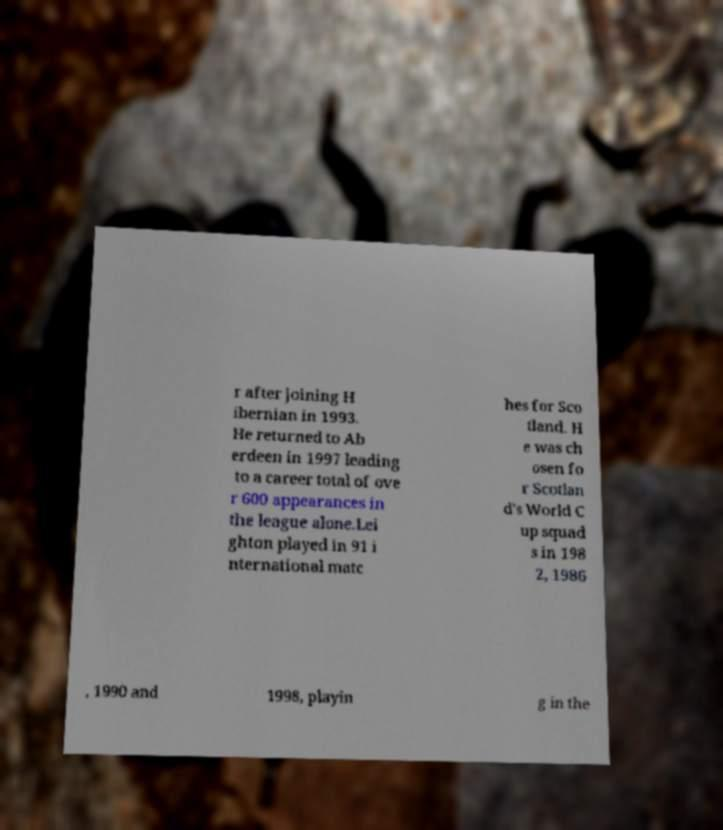Please identify and transcribe the text found in this image. r after joining H ibernian in 1993. He returned to Ab erdeen in 1997 leading to a career total of ove r 600 appearances in the league alone.Lei ghton played in 91 i nternational matc hes for Sco tland. H e was ch osen fo r Scotlan d's World C up squad s in 198 2, 1986 , 1990 and 1998, playin g in the 